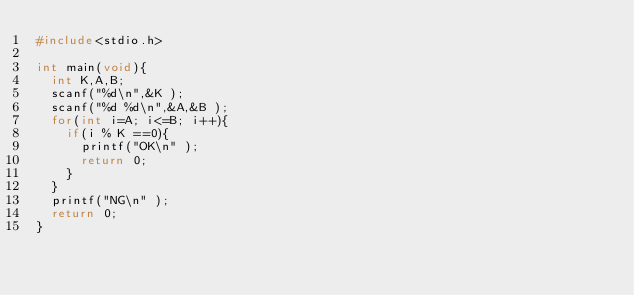<code> <loc_0><loc_0><loc_500><loc_500><_C_>#include<stdio.h>

int main(void){
  int K,A,B;
  scanf("%d\n",&K );
  scanf("%d %d\n",&A,&B );
  for(int i=A; i<=B; i++){
    if(i % K ==0){
      printf("OK\n" );
      return 0;
    }
  }
  printf("NG\n" );
  return 0;
}
</code> 